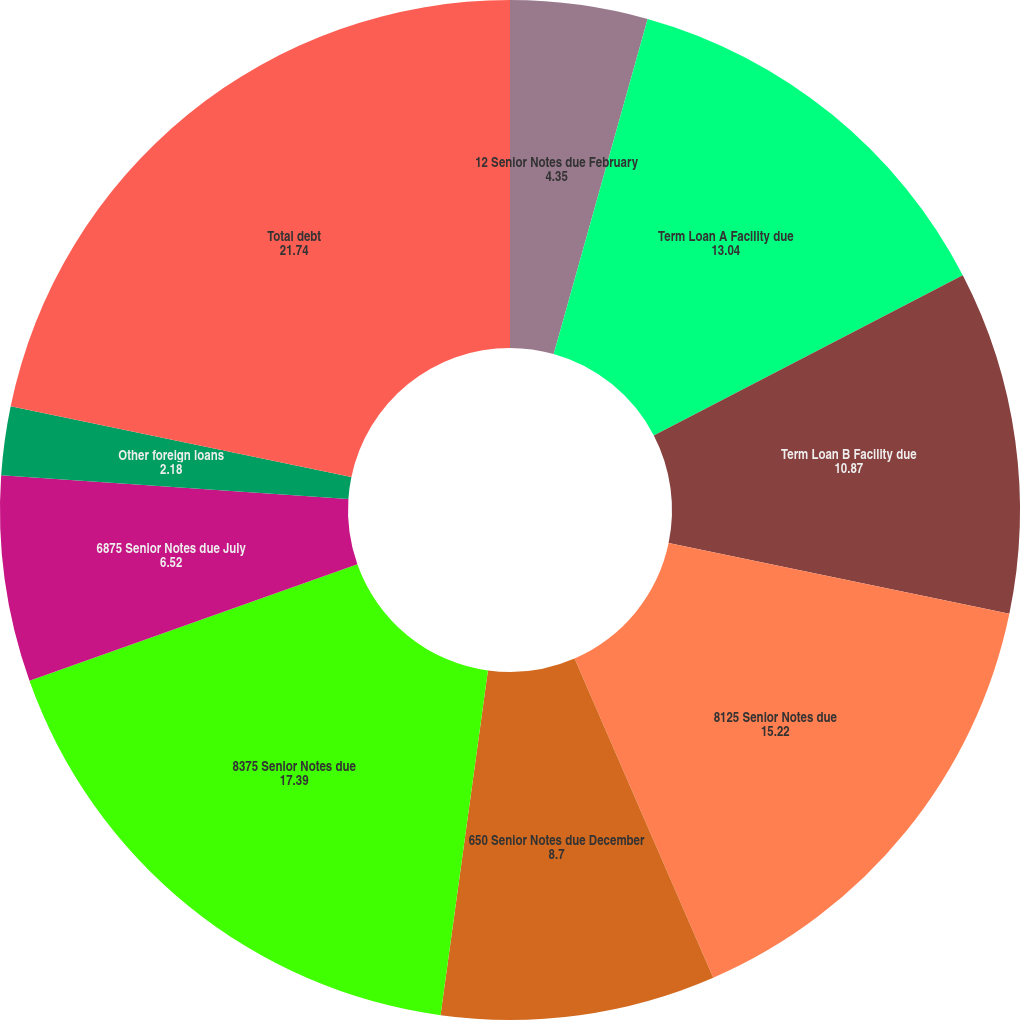<chart> <loc_0><loc_0><loc_500><loc_500><pie_chart><fcel>12 Senior Notes due February<fcel>Term Loan A Facility due<fcel>Term Loan B Facility due<fcel>8125 Senior Notes due<fcel>650 Senior Notes due December<fcel>8375 Senior Notes due<fcel>6875 Senior Notes due July<fcel>Other foreign loans<fcel>Other domestic loans<fcel>Total debt<nl><fcel>4.35%<fcel>13.04%<fcel>10.87%<fcel>15.22%<fcel>8.7%<fcel>17.39%<fcel>6.52%<fcel>2.18%<fcel>0.0%<fcel>21.74%<nl></chart> 